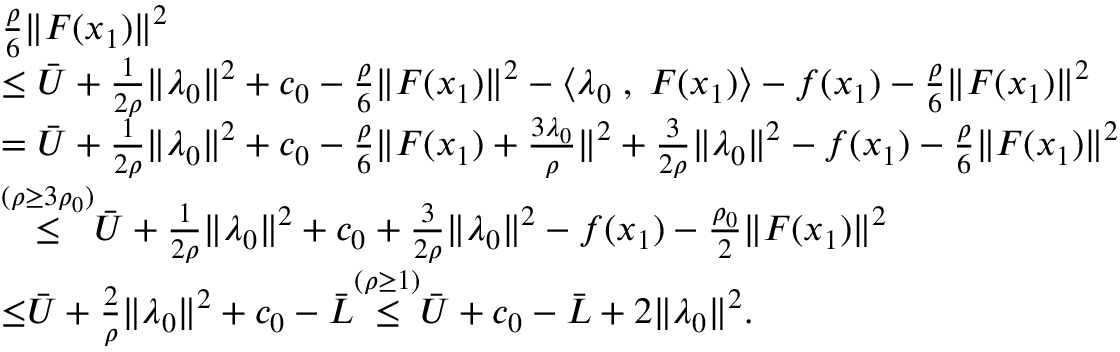Convert formula to latex. <formula><loc_0><loc_0><loc_500><loc_500>\begin{array} { r l } & { \frac { \rho } { 6 } \| F ( x _ { 1 } ) \| ^ { 2 } } \\ & { \leq \bar { U } + \frac { 1 } { 2 \rho } \| \lambda _ { 0 } \| ^ { 2 } + c _ { 0 } - \frac { \rho } { 6 } \| F ( x _ { 1 } ) \| ^ { 2 } - \langle \lambda _ { 0 } \, , \, F ( x _ { 1 } ) \rangle - f ( x _ { 1 } ) - \frac { \rho } { 6 } \| F ( x _ { 1 } ) \| ^ { 2 } } \\ & { = \bar { U } + \frac { 1 } { 2 \rho } \| \lambda _ { 0 } \| ^ { 2 } + c _ { 0 } - \frac { \rho } { 6 } \| F ( x _ { 1 } ) + \frac { 3 \lambda _ { 0 } } { \rho } \| ^ { 2 } + \frac { 3 } { 2 \rho } \| \lambda _ { 0 } \| ^ { 2 } - f ( x _ { 1 } ) - \frac { \rho } { 6 } \| F ( x _ { 1 } ) \| ^ { 2 } } \\ & { { \overset { { ( \rho \geq 3 \rho _ { 0 } ) } } { \leq } } \bar { U } + \frac { 1 } { 2 \rho } \| \lambda _ { 0 } \| ^ { 2 } + c _ { 0 } + \frac { 3 } { 2 \rho } \| \lambda _ { 0 } \| ^ { 2 } - f ( x _ { 1 } ) - \frac { \rho _ { 0 } } { 2 } \| F ( x _ { 1 } ) \| ^ { 2 } } \\ & { { { \leq } } \bar { U } + \frac { 2 } { \rho } \| \lambda _ { 0 } \| ^ { 2 } + c _ { 0 } - \bar { L } { \overset { ( \rho \geq 1 ) } { \leq } } \bar { U } + c _ { 0 } - \bar { L } + { 2 } \| \lambda _ { 0 } \| ^ { 2 } . } \end{array}</formula> 